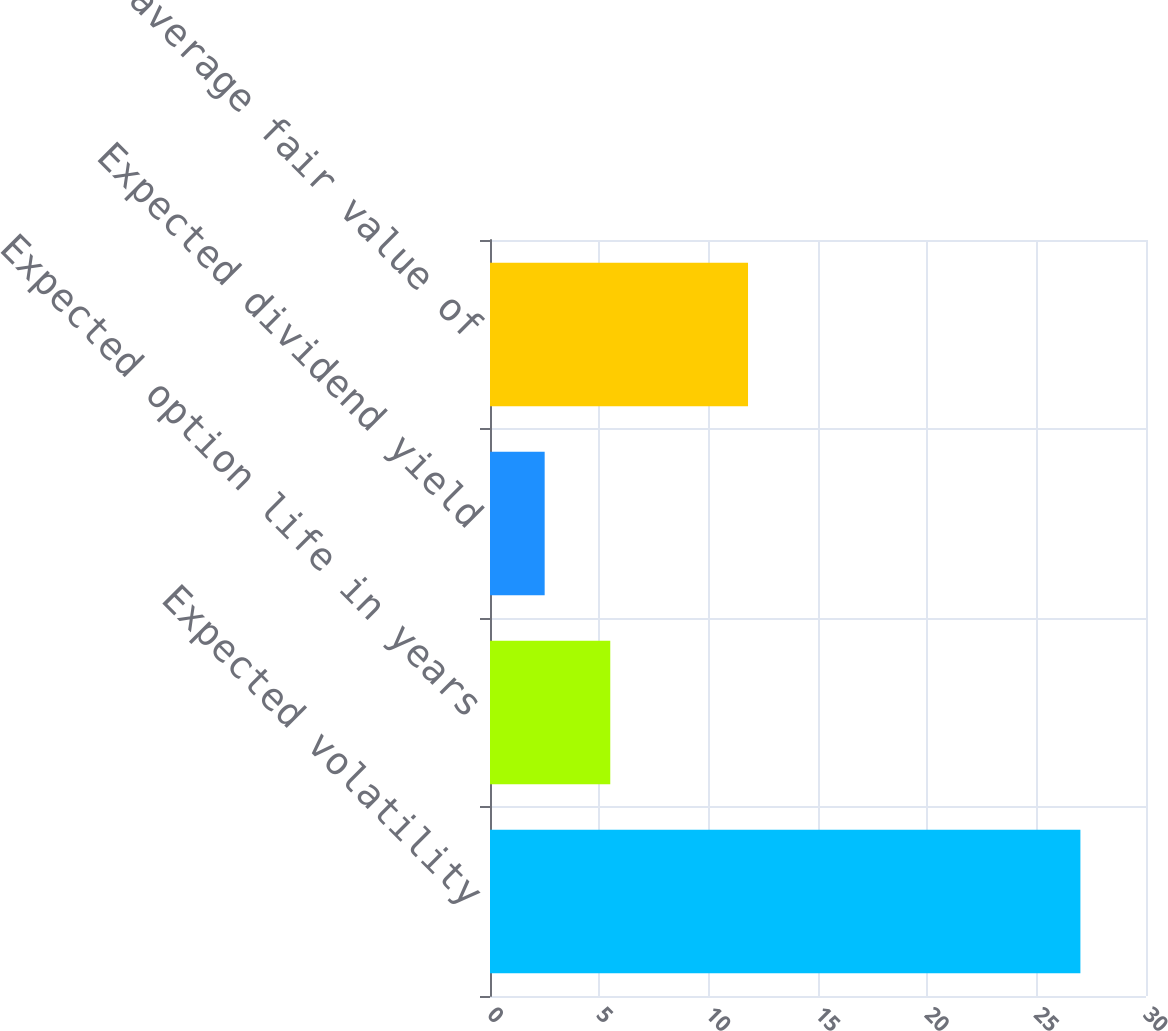Convert chart. <chart><loc_0><loc_0><loc_500><loc_500><bar_chart><fcel>Expected volatility<fcel>Expected option life in years<fcel>Expected dividend yield<fcel>Weighted-average fair value of<nl><fcel>27<fcel>5.5<fcel>2.5<fcel>11.8<nl></chart> 